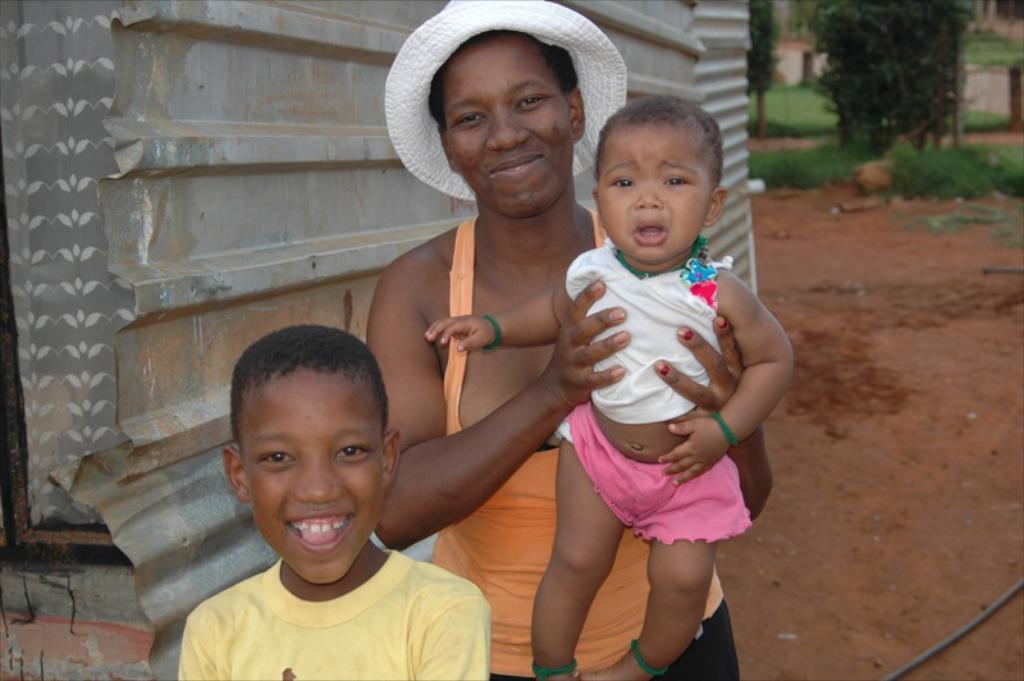Could you give a brief overview of what you see in this image? In the center of the image, we can see a boy smiling and there is a lady holding a baby and in the background, we can see a shed and there are trees. At the bottom, there is ground. 